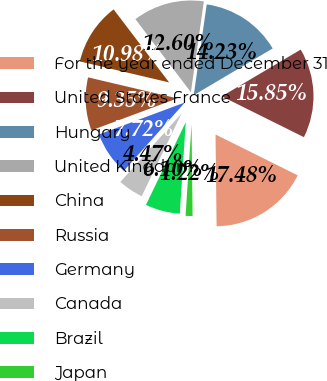Convert chart. <chart><loc_0><loc_0><loc_500><loc_500><pie_chart><fcel>For the year ended December 31<fcel>United States France<fcel>Hungary<fcel>United Kingdom<fcel>China<fcel>Russia<fcel>Germany<fcel>Canada<fcel>Brazil<fcel>Japan<nl><fcel>17.48%<fcel>15.85%<fcel>14.23%<fcel>12.6%<fcel>10.98%<fcel>9.35%<fcel>7.72%<fcel>4.47%<fcel>6.1%<fcel>1.22%<nl></chart> 